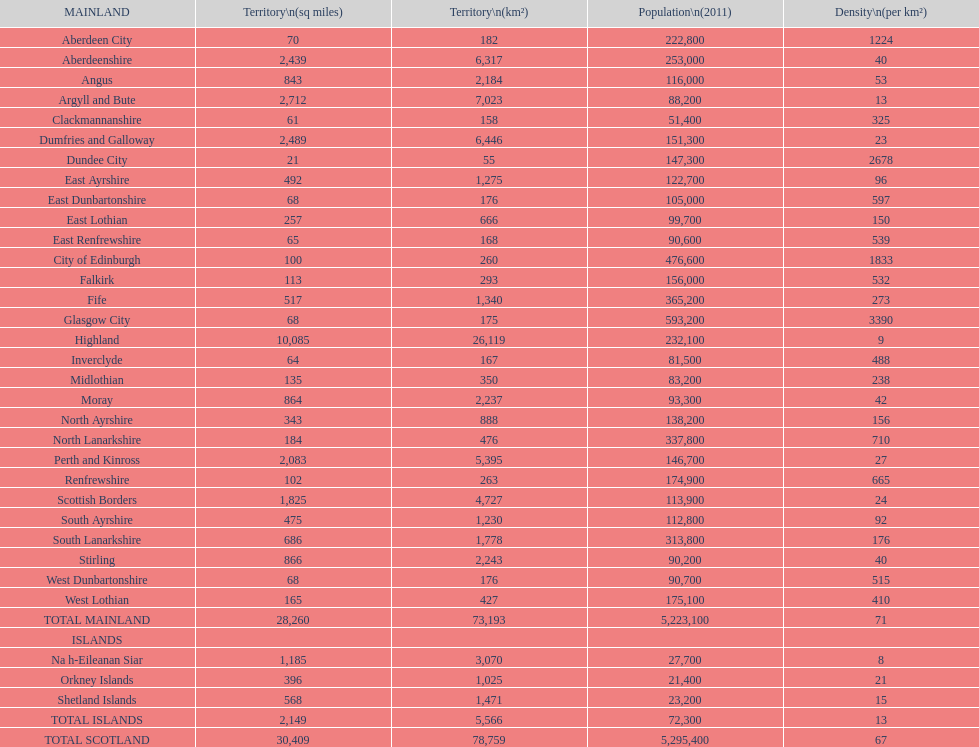How many inhabitants were there in angus in 2011? 116,000. 